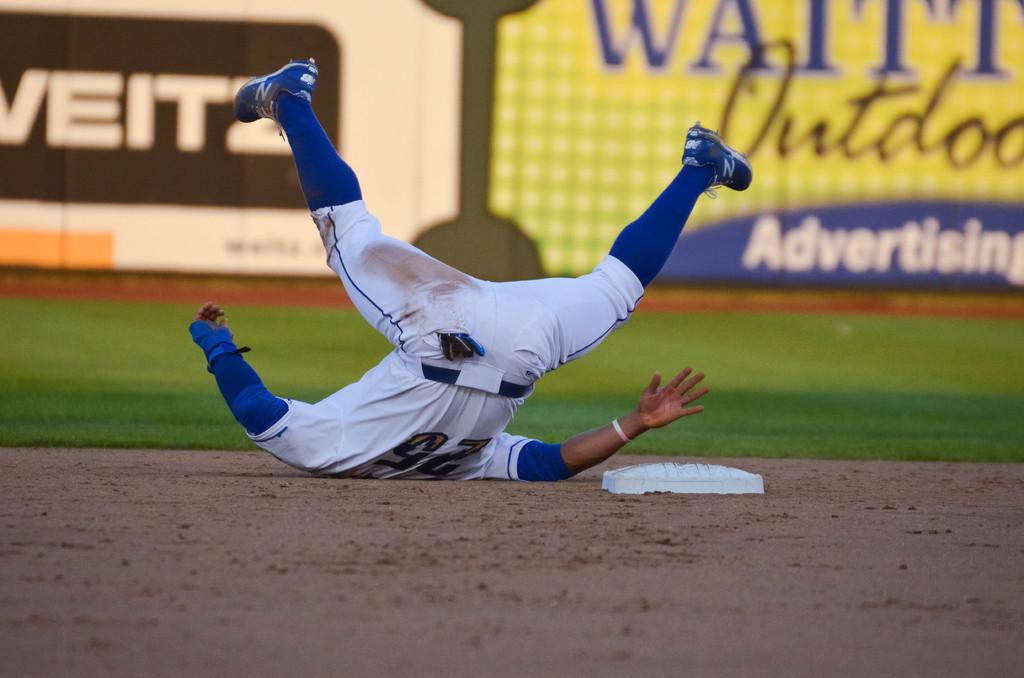<image>
Give a short and clear explanation of the subsequent image. Number 25 is flipped over on his back by second base. 